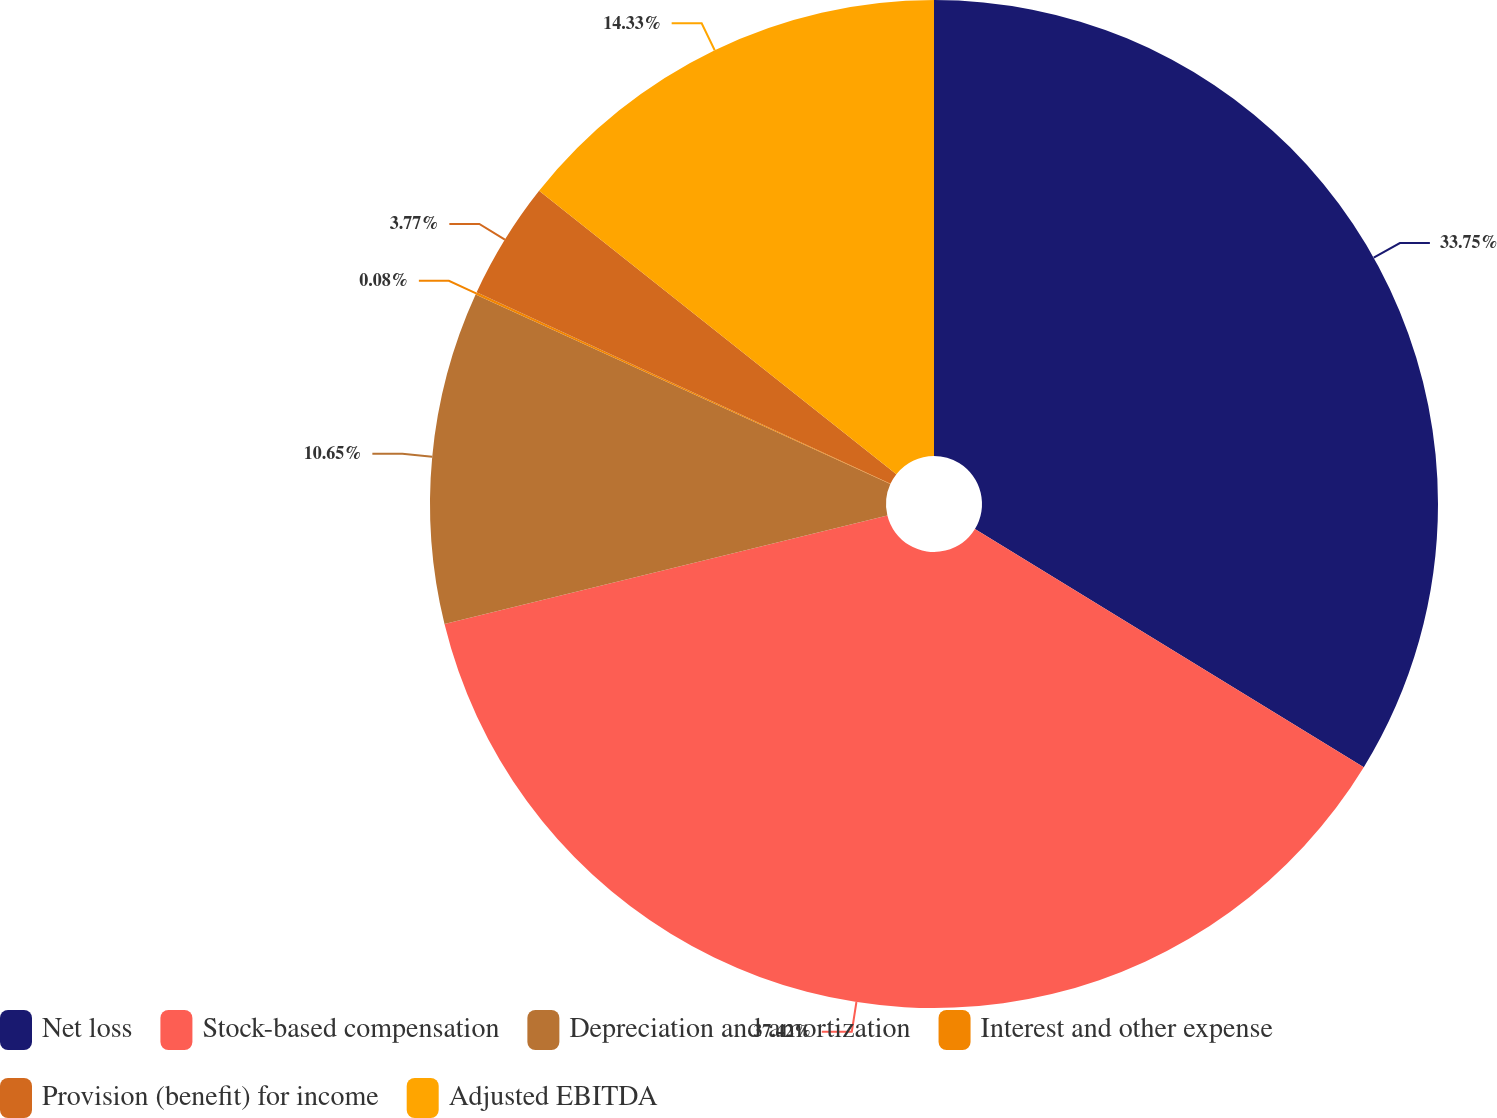Convert chart to OTSL. <chart><loc_0><loc_0><loc_500><loc_500><pie_chart><fcel>Net loss<fcel>Stock-based compensation<fcel>Depreciation and amortization<fcel>Interest and other expense<fcel>Provision (benefit) for income<fcel>Adjusted EBITDA<nl><fcel>33.75%<fcel>37.43%<fcel>10.65%<fcel>0.08%<fcel>3.77%<fcel>14.33%<nl></chart> 